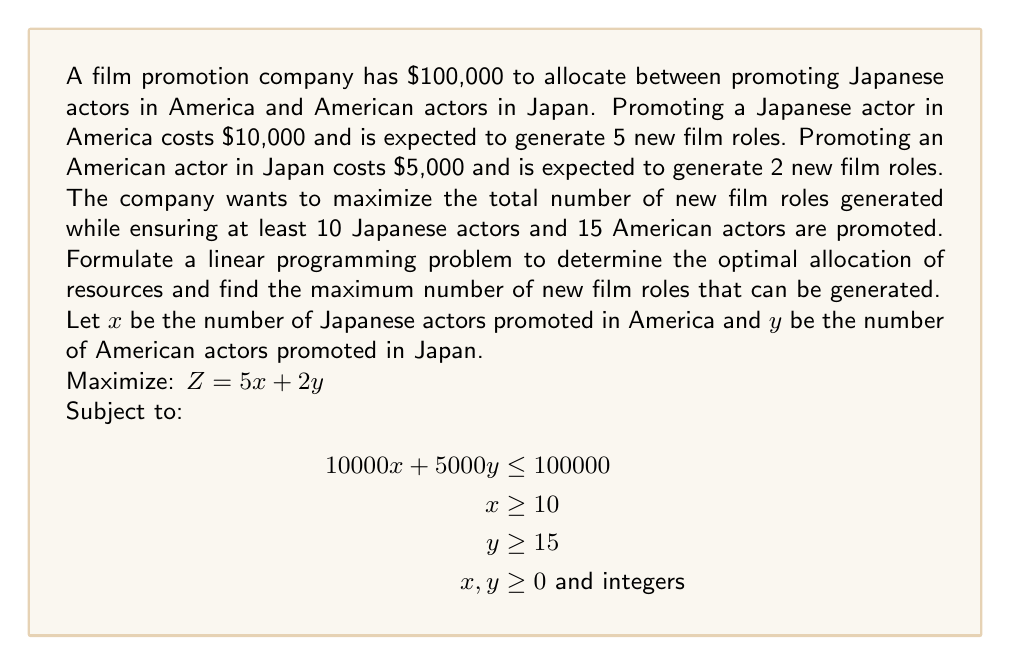Show me your answer to this math problem. To solve this linear programming problem, we'll follow these steps:

1) First, let's rewrite the constraints in standard form:
   $10000x + 5000y \leq 100000$
   $-x \leq -10$
   $-y \leq -15$

2) We can solve this graphically by plotting these constraints:

   [asy]
   import geometry;

   size(200);
   
   real xmax = 12;
   real ymax = 24;
   
   xaxis("x", 0, xmax, arrow=Arrow);
   yaxis("y", 0, ymax, arrow=Arrow);
   
   path budget = (0,20)--(10,0);
   path minx = (10,0)--(10,ymax);
   path miny = (0,15)--(xmax,15);
   
   draw(budget, red);
   draw(minx, blue);
   draw(miny, green);
   
   label("Budget constraint", (5,10), E, red);
   label("Min Japanese actors", (10,20), W, blue);
   label("Min American actors", (6,15), N, green);
   
   dot((10,15));
   label("(10,15)", (10,15), SE);
   
   dot((10,16));
   label("(10,16)", (10,16), SE);
   [/asy]

3) The feasible region is the area that satisfies all constraints. From the graph, we can see that the corner points of the feasible region are (10,15) and (10,16).

4) We evaluate the objective function at these points:
   At (10,15): $Z = 5(10) + 2(15) = 80$
   At (10,16): $Z = 5(10) + 2(16) = 82$

5) The maximum value of Z occurs at (10,16), which means we should promote 10 Japanese actors in America and 16 American actors in Japan.

6) This allocation uses:
   $10 * 10000 + 16 * 5000 = 100000 + 80000 = 180000$
   Which is within our budget of $100,000.

Therefore, the optimal solution is to promote 10 Japanese actors in America and 16 American actors in Japan, which will generate a maximum of 82 new film roles.
Answer: The maximum number of new film roles that can be generated is 82, achieved by promoting 10 Japanese actors in America and 16 American actors in Japan. 